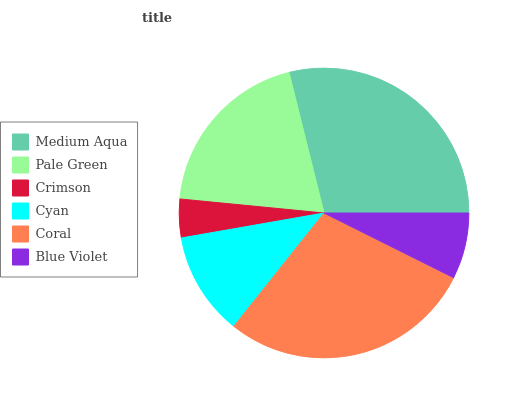Is Crimson the minimum?
Answer yes or no. Yes. Is Medium Aqua the maximum?
Answer yes or no. Yes. Is Pale Green the minimum?
Answer yes or no. No. Is Pale Green the maximum?
Answer yes or no. No. Is Medium Aqua greater than Pale Green?
Answer yes or no. Yes. Is Pale Green less than Medium Aqua?
Answer yes or no. Yes. Is Pale Green greater than Medium Aqua?
Answer yes or no. No. Is Medium Aqua less than Pale Green?
Answer yes or no. No. Is Pale Green the high median?
Answer yes or no. Yes. Is Cyan the low median?
Answer yes or no. Yes. Is Coral the high median?
Answer yes or no. No. Is Blue Violet the low median?
Answer yes or no. No. 